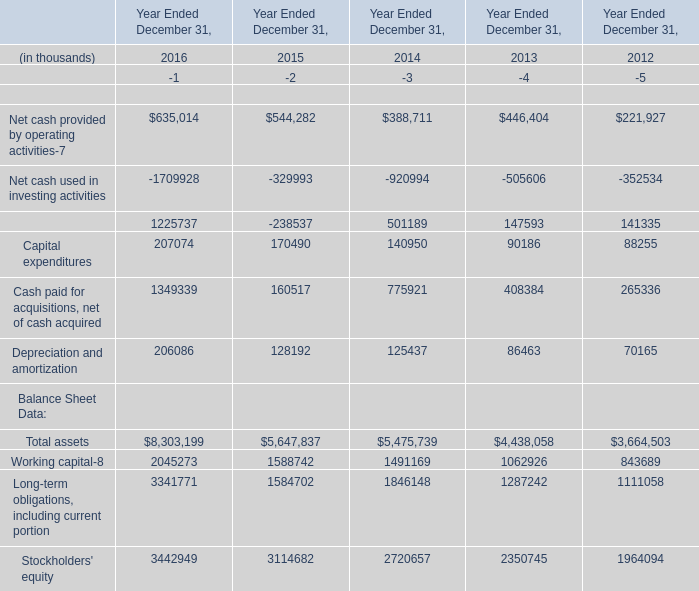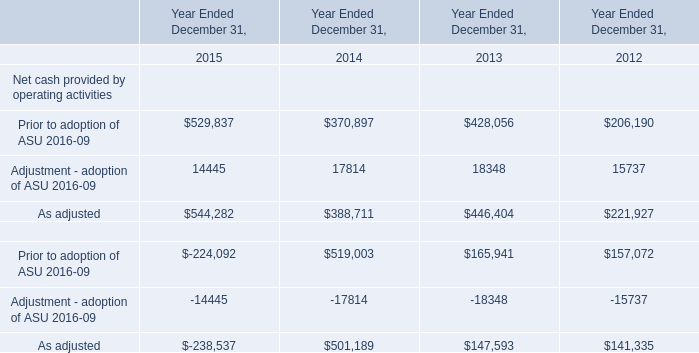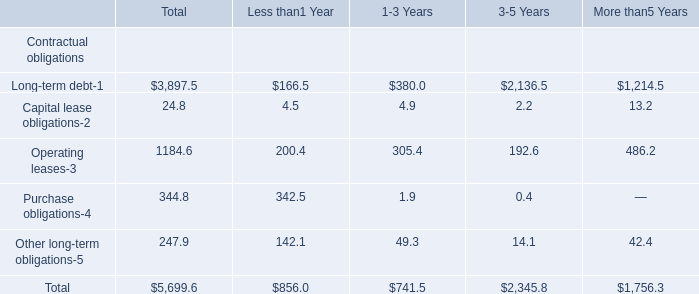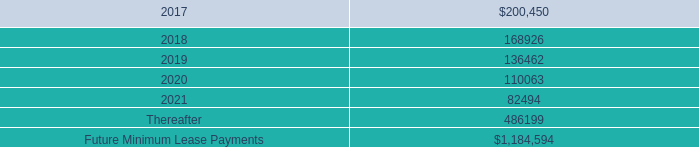what was the cumulative rental expense from 2014 to 2016 in millions 
Computations: (148.5 + (211.5 + 168.4))
Answer: 528.4. 